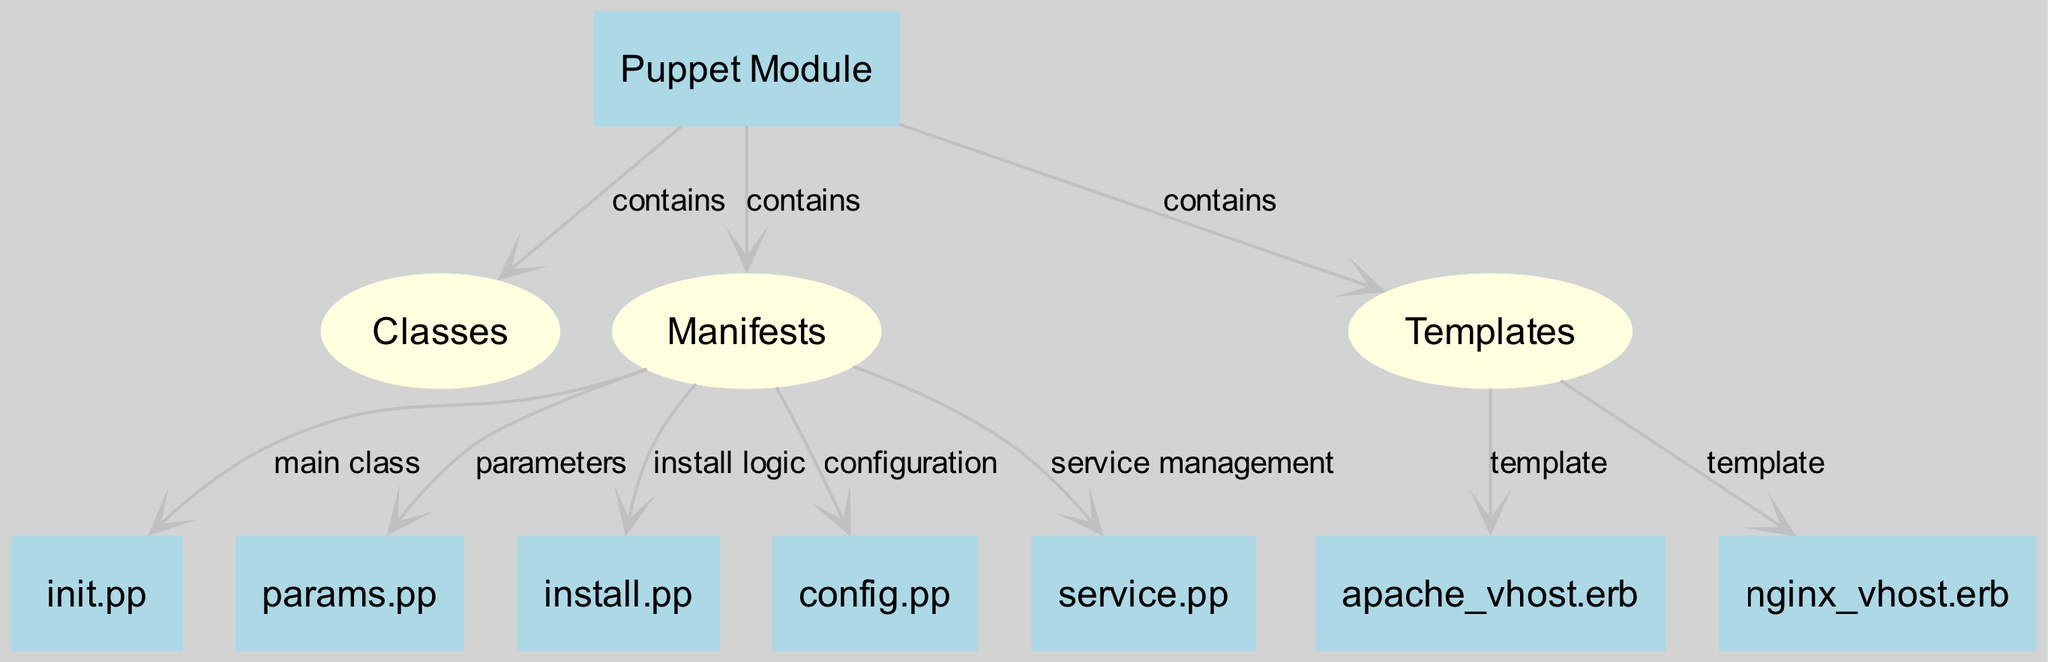What is the main class in the Puppet module structure? The main class in the Puppet module structure is identified within the manifests section. It is represented by the "init.pp" node, which is connected to the manifests node and labeled as the main class.
Answer: init.pp How many templates are present in the Puppet module? By examining the templates node, we see that there are two connections leading to individual template files: "apache_vhost.erb" and "nginx_vhost.erb." Therefore, there are two templates present in the Puppet module.
Answer: 2 Which node contains service management logic? The node that represents service management logic is "service.pp," which is connected to the manifests node and specifically labeled as handling service management.
Answer: service.pp What is included in the parameters node? The parameters node corresponds to the "params.pp," which is connected to the manifests node and labeled for handling parameters within the module.
Answer: params.pp What is the relationship between Puppet module and templates? The relationship between the Puppet module and templates is that the Puppet module contains templates, as evidenced by the connection from the puppet_module node to the templates node labeled as "contains."
Answer: contains Which manifest handles installation logic? The manifest that handles installation logic is the "install.pp" node, which is directly connected to the manifests node and labeled as responsible for installation logic.
Answer: install.pp How many nodes are classified as boxes in the diagram? By counting all nodes classified with the shape "box," we can see that there are seven box-shaped nodes: "Puppet Module," "init.pp," "params.pp," "install.pp," "config.pp," "service.pp," and the two templates do not count. Therefore, there are a total of seven box-shaped nodes in the diagram.
Answer: 7 Which template is associated with Apache virtual hosts? The template associated with Apache virtual hosts is identified by the node "apache_vhost.erb," which is connected to the templates node in the diagram.
Answer: apache_vhost.erb What function does the config.pp file serve? The "config.pp" file serves the function of configuration within the manifests node, as indicated by its connection and specific label regarding configuration.
Answer: configuration 